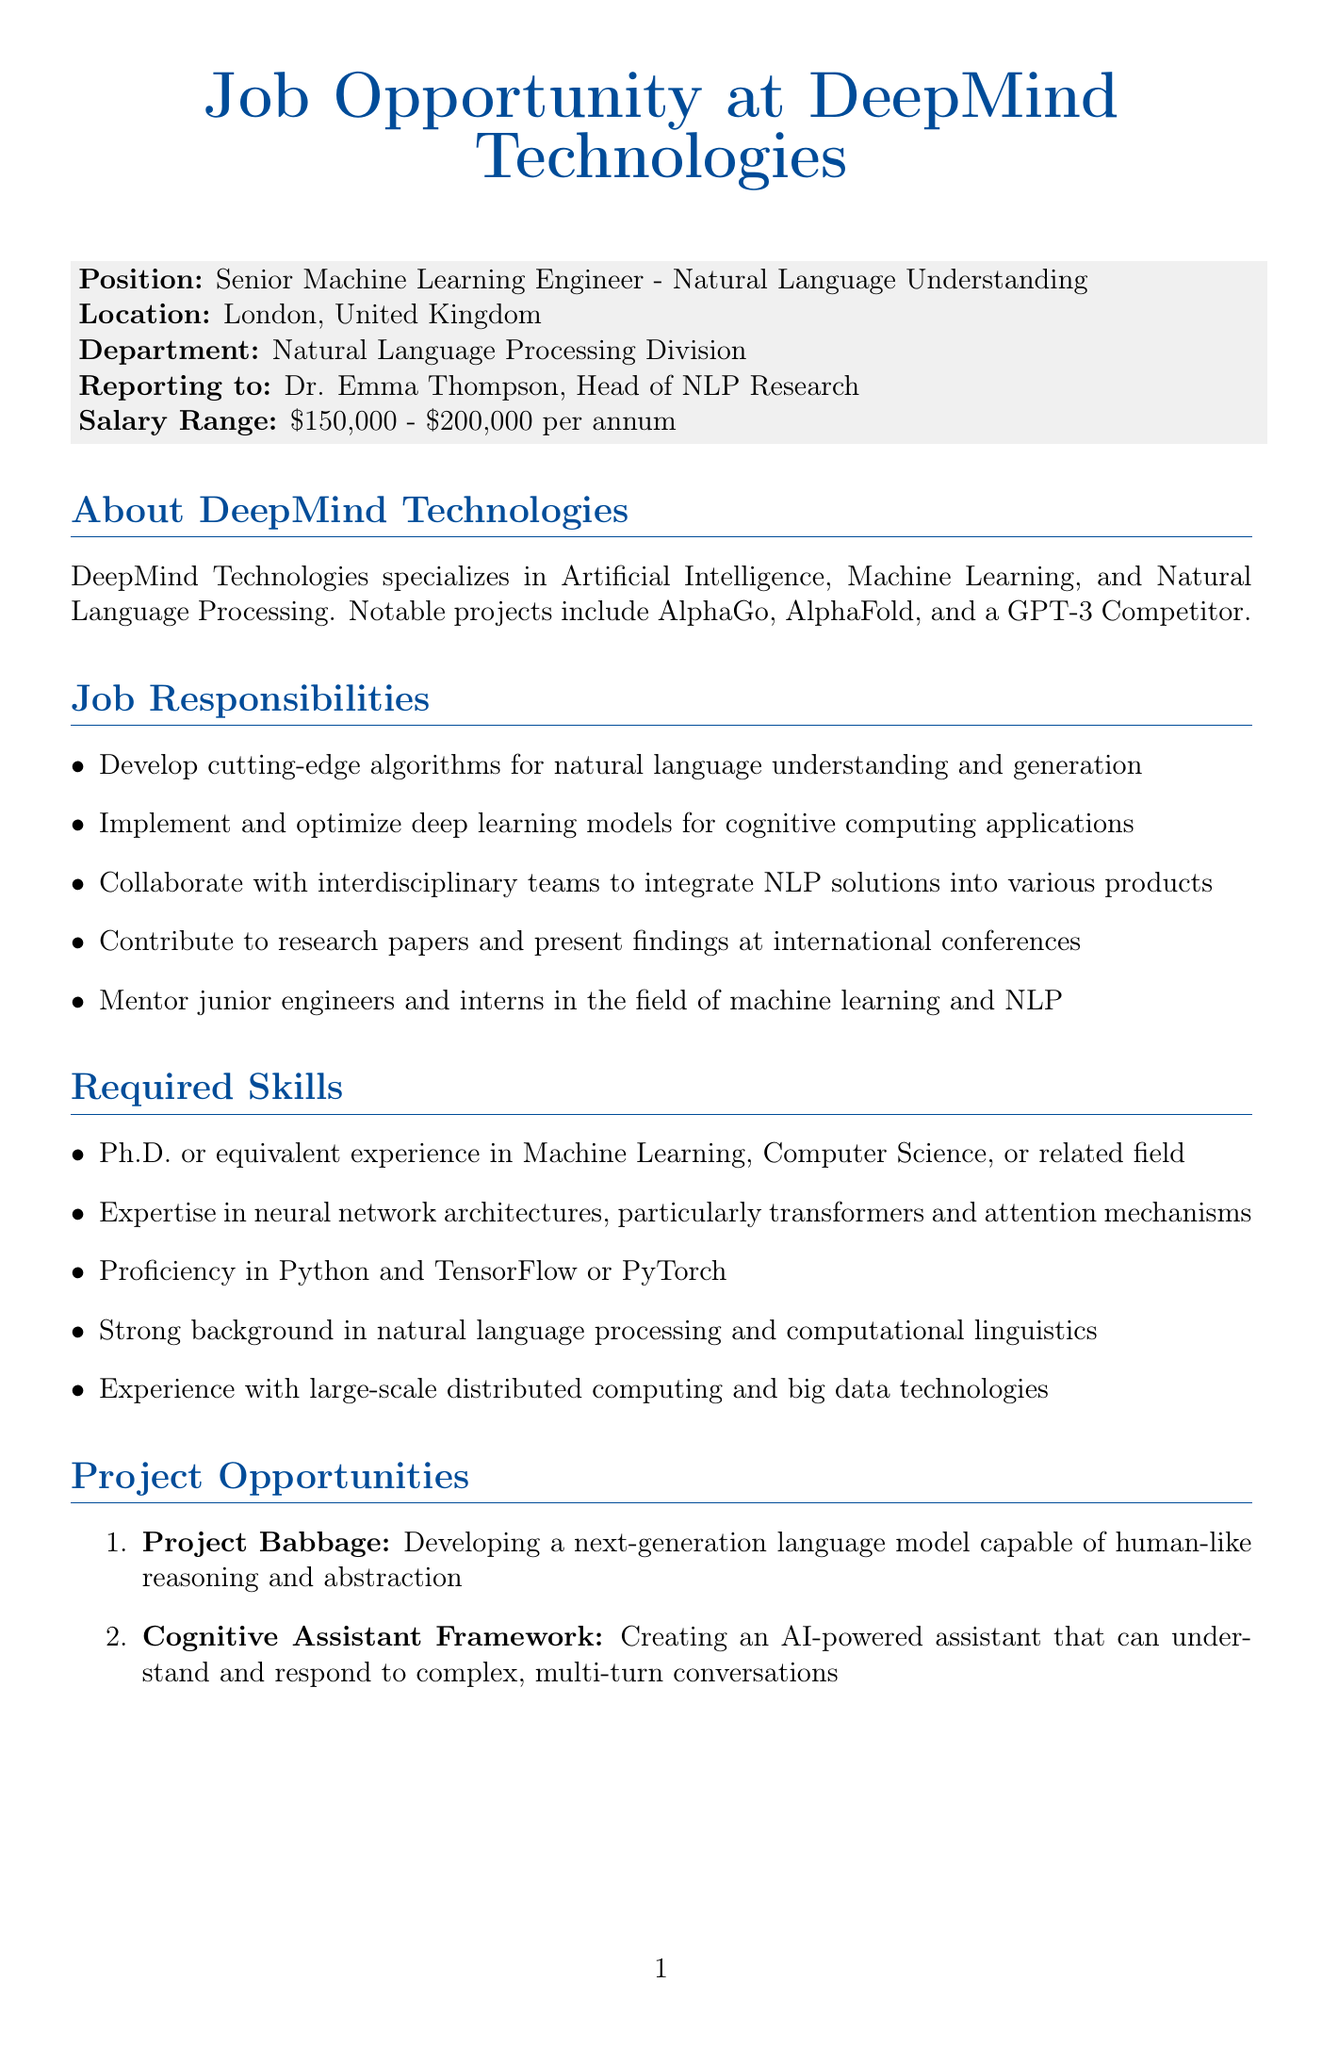what is the name of the company? The document states the name of the company as DeepMind Technologies.
Answer: DeepMind Technologies what is the job title for the position offered? The job title mentioned in the document is Senior Machine Learning Engineer - Natural Language Understanding.
Answer: Senior Machine Learning Engineer - Natural Language Understanding who is the position reporting to? The document indicates that the position reports to Dr. Emma Thompson, the Head of NLP Research.
Answer: Dr. Emma Thompson what is the salary range for the position? The salary range provided in the document is between $150,000 and $200,000 per annum.
Answer: $150,000 - $200,000 per annum how many project opportunities are listed in the document? The document lists two project opportunities under Project Opportunities.
Answer: 2 what are the values emphasized by the company? The document mentions Innovation, Collaboration, and Ethical AI Development as the company's values.
Answer: Innovation, Collaboration, Ethical AI Development how long does the application process take? According to the document, the timeline for the application process is 4 to 6 weeks from application to offer.
Answer: 4-6 weeks what type of skills are required for the position? The required skills include a Ph.D. or equivalent experience in Machine Learning, which indicates the expertise needed for the role.
Answer: Ph.D. or equivalent experience in Machine Learning what is one of the notable projects mentioned? The document lists AlphaGo as one of the notable projects of the company.
Answer: AlphaGo 